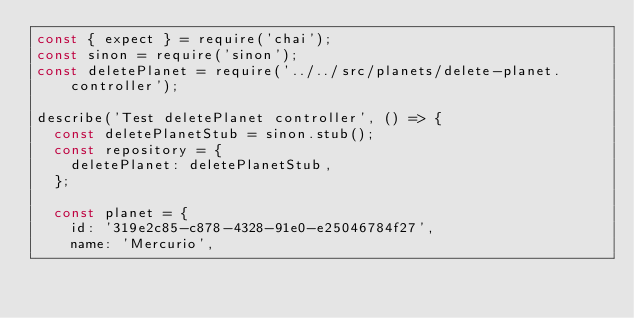<code> <loc_0><loc_0><loc_500><loc_500><_JavaScript_>const { expect } = require('chai');
const sinon = require('sinon');
const deletePlanet = require('../../src/planets/delete-planet.controller');

describe('Test deletePlanet controller', () => {
  const deletePlanetStub = sinon.stub();
  const repository = {
    deletePlanet: deletePlanetStub,
  };

  const planet = {
    id: '319e2c85-c878-4328-91e0-e25046784f27',
    name: 'Mercurio',</code> 